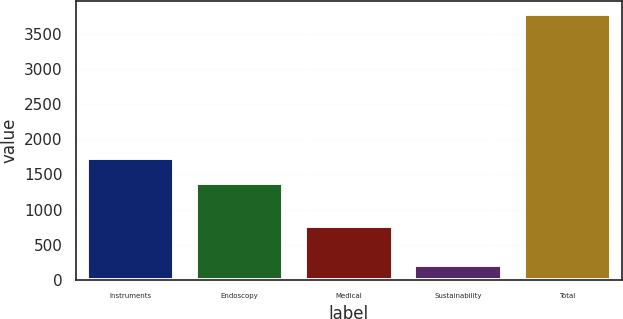<chart> <loc_0><loc_0><loc_500><loc_500><bar_chart><fcel>Instruments<fcel>Endoscopy<fcel>Medical<fcel>Sustainability<fcel>Total<nl><fcel>1739.2<fcel>1382<fcel>766<fcel>209<fcel>3781<nl></chart> 